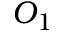Convert formula to latex. <formula><loc_0><loc_0><loc_500><loc_500>O _ { 1 }</formula> 